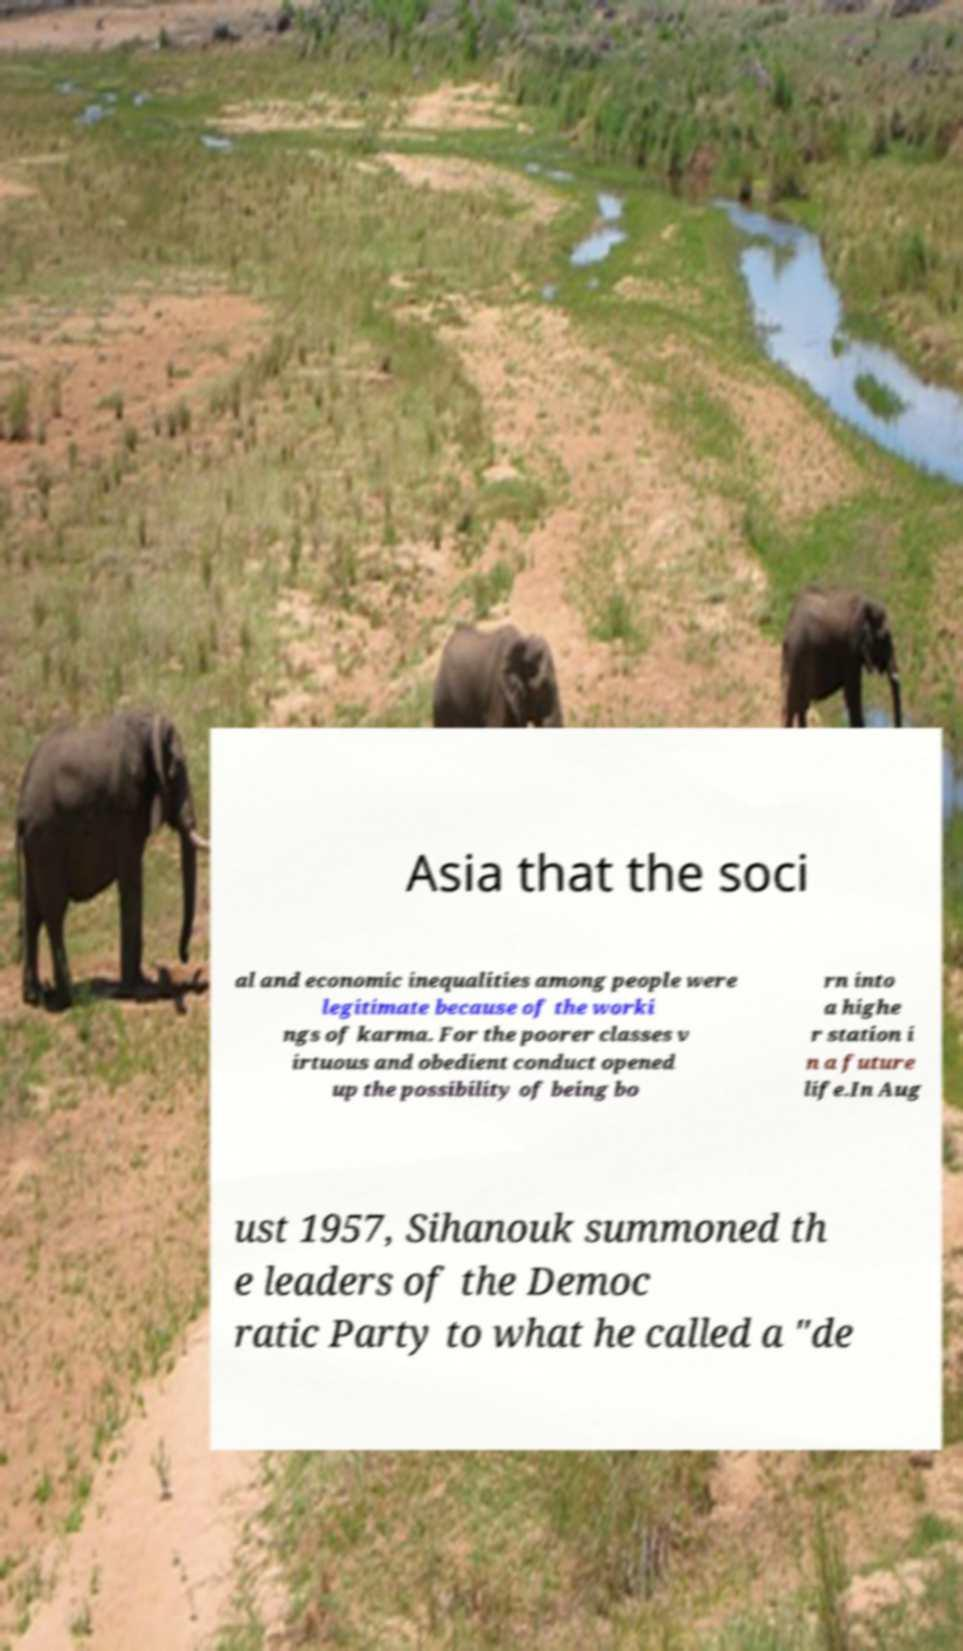Please read and relay the text visible in this image. What does it say? Asia that the soci al and economic inequalities among people were legitimate because of the worki ngs of karma. For the poorer classes v irtuous and obedient conduct opened up the possibility of being bo rn into a highe r station i n a future life.In Aug ust 1957, Sihanouk summoned th e leaders of the Democ ratic Party to what he called a "de 